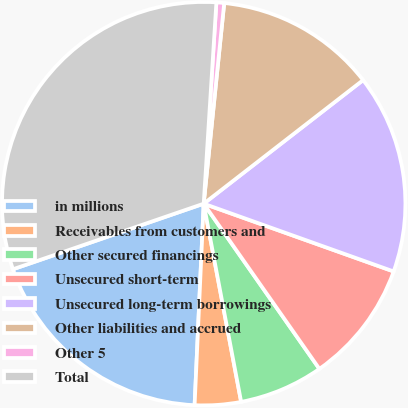Convert chart to OTSL. <chart><loc_0><loc_0><loc_500><loc_500><pie_chart><fcel>in millions<fcel>Receivables from customers and<fcel>Other secured financings<fcel>Unsecured short-term<fcel>Unsecured long-term borrowings<fcel>Other liabilities and accrued<fcel>Other 5<fcel>Total<nl><fcel>19.01%<fcel>3.69%<fcel>6.75%<fcel>9.82%<fcel>15.95%<fcel>12.88%<fcel>0.62%<fcel>31.27%<nl></chart> 